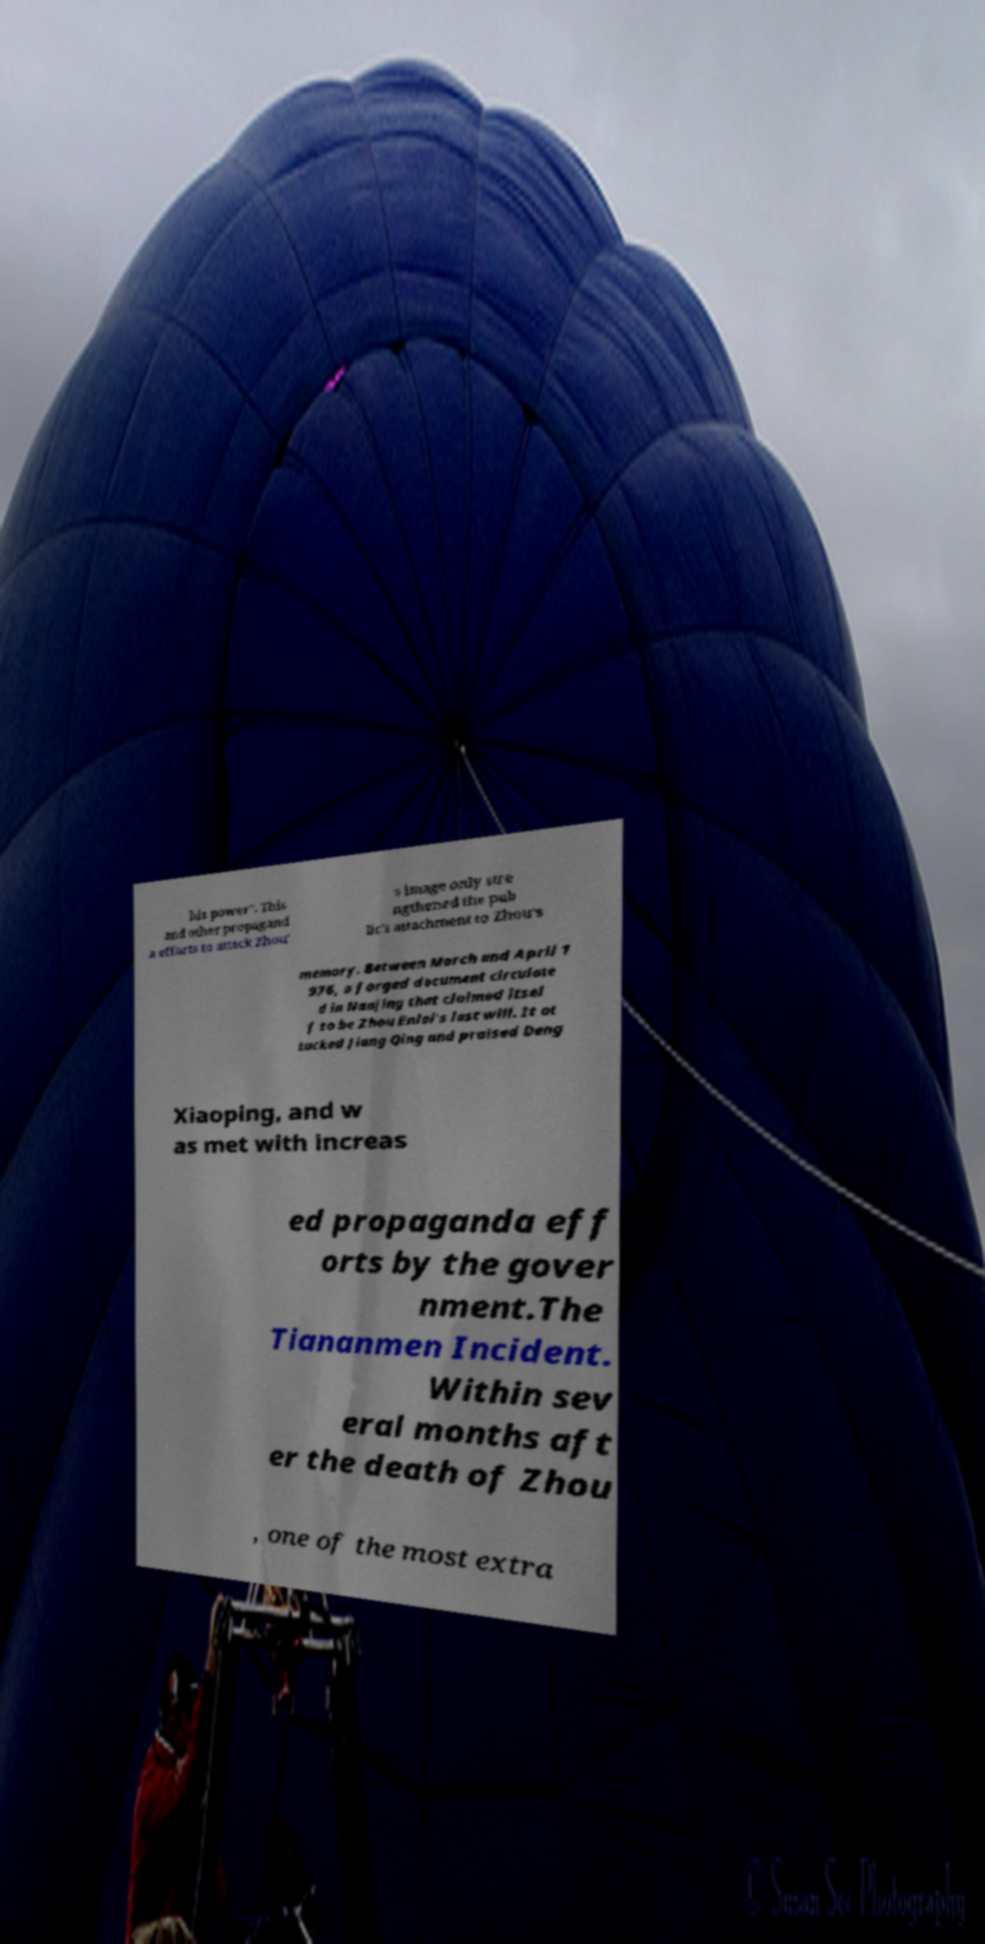Could you extract and type out the text from this image? his power". This and other propagand a efforts to attack Zhou' s image only stre ngthened the pub lic's attachment to Zhou's memory. Between March and April 1 976, a forged document circulate d in Nanjing that claimed itsel f to be Zhou Enlai's last will. It at tacked Jiang Qing and praised Deng Xiaoping, and w as met with increas ed propaganda eff orts by the gover nment.The Tiananmen Incident. Within sev eral months aft er the death of Zhou , one of the most extra 